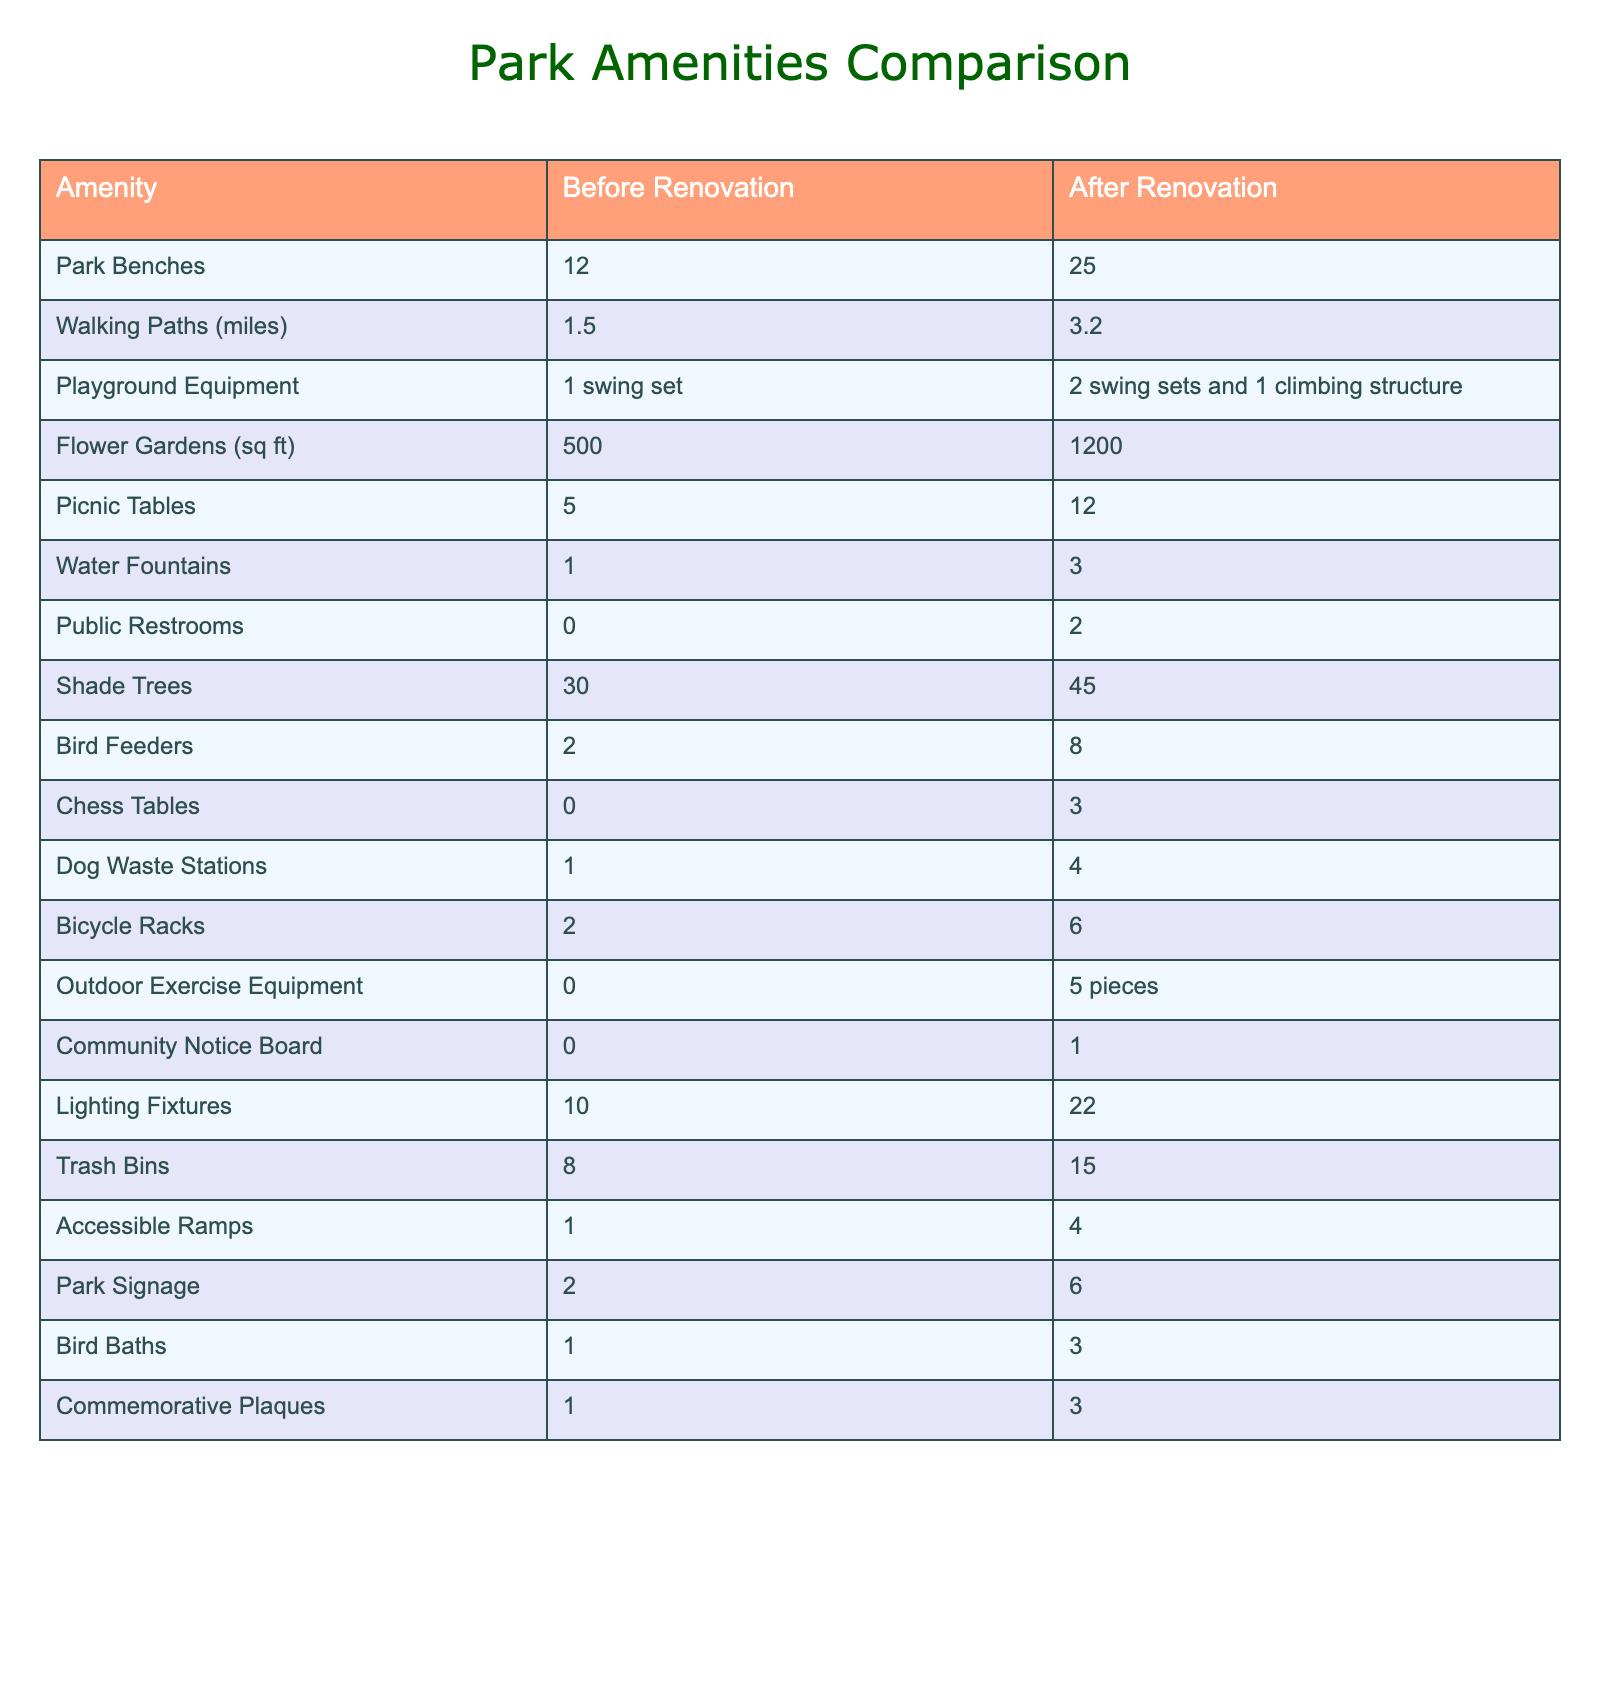What is the total number of park benches before the renovation? The table shows that there were 12 park benches before the renovation.
Answer: 12 How many more picnic tables are there after the renovation compared to before? After the renovation, there are 12 picnic tables, and before there were 5. The difference is 12 - 5 = 7.
Answer: 7 Did the number of public restrooms increase after the renovations? The table indicates that there were no public restrooms before the renovation (0) and now there are 2 after the renovation. Therefore, the number of public restrooms did increase.
Answer: Yes How many more flower garden square feet are there after the renovation compared to before? Before the renovation, there were 500 square feet of flower gardens, and after, there are 1200 square feet. The increase is 1200 - 500 = 700 square feet.
Answer: 700 square feet What is the percentage increase in the number of bird feeders after the renovations? Before the renovation, there were 2 bird feeders, and after, there are 8. The increase is 8 - 2 = 6. To find the percentage increase, the formula is (Increase/Old Value) * 100. Thus, (6/2) * 100 = 300%.
Answer: 300% How many amenities had an increase of more than 3 units after renovation? By analyzing the data, we look for amenities with an increase of more than 3. The amenities are park benches (13 increase), walking paths (1.7 increase), picnic tables (7 increase), water fountains (2 increase), shade trees (15 increase), dog waste stations (3 increase), bicycle racks (4 increase), outdoor exercise equipment (5), lighting fixtures (12), trash bins (7), and accessible ramps (3). Counting these amenities gives us a total of 8 that increased by more than 3 units.
Answer: 8 Is there outdoor exercise equipment available in the park before renovations? According to the table, there were 0 pieces of outdoor exercise equipment before the renovation.
Answer: No What is the total number of trash bins available after renovations? The table states there are 15 trash bins after the renovation.
Answer: 15 How many more shade trees are there after the renovation than before? The table records 30 shade trees before and 45 after the renovation. The difference is 45 - 30 = 15.
Answer: 15 